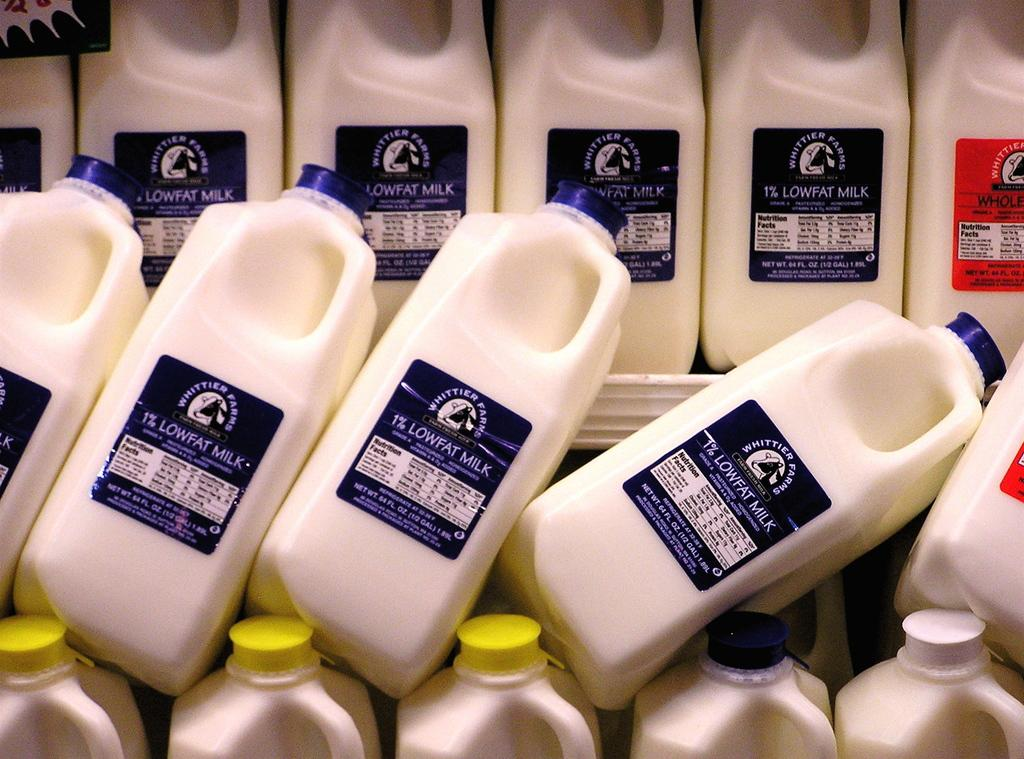<image>
Present a compact description of the photo's key features. cartons of milk that read 'lowfat milk' on them 